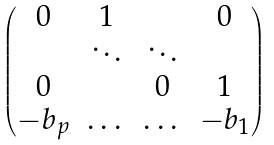<formula> <loc_0><loc_0><loc_500><loc_500>\begin{pmatrix} 0 & 1 & & 0 \\ & \ddots & \ddots & \\ 0 & & 0 & 1 \\ - b _ { p } & \dots & \dots & - b _ { 1 } \\ \end{pmatrix}</formula> 